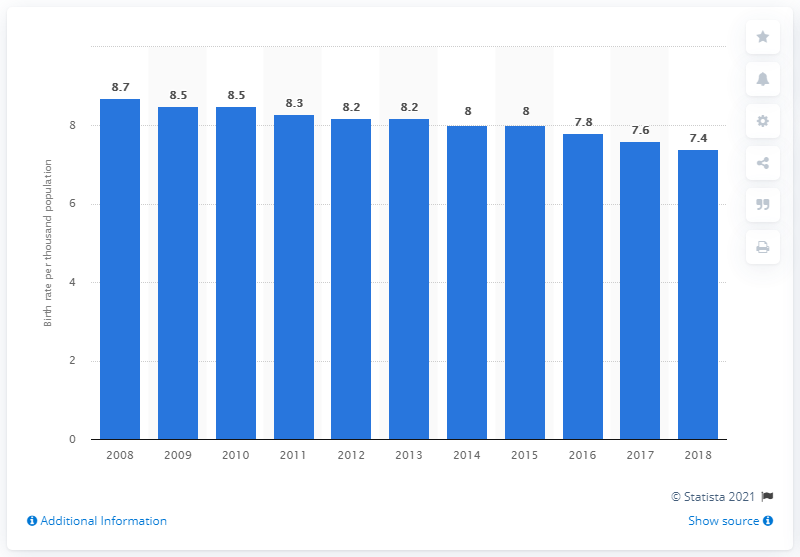Give some essential details in this illustration. In 2018, the crude birth rate in Japan was 7.4. 